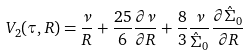<formula> <loc_0><loc_0><loc_500><loc_500>V _ { 2 } ( \tau , R ) = \frac { \nu } { R } + \frac { 2 5 } { 6 } \frac { \partial \nu } { \partial R } + \frac { 8 } { 3 } \frac { \nu } { \hat { \Sigma } _ { 0 } } \frac { \partial \hat { \Sigma } _ { 0 } } { \partial R }</formula> 